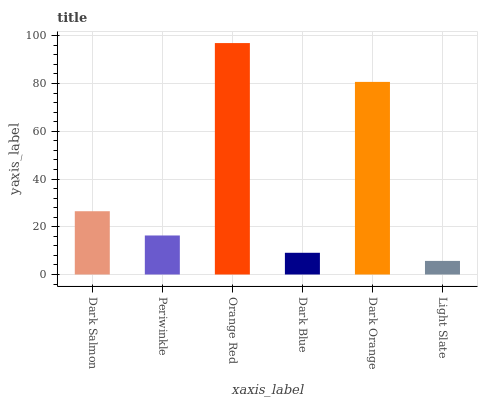Is Light Slate the minimum?
Answer yes or no. Yes. Is Orange Red the maximum?
Answer yes or no. Yes. Is Periwinkle the minimum?
Answer yes or no. No. Is Periwinkle the maximum?
Answer yes or no. No. Is Dark Salmon greater than Periwinkle?
Answer yes or no. Yes. Is Periwinkle less than Dark Salmon?
Answer yes or no. Yes. Is Periwinkle greater than Dark Salmon?
Answer yes or no. No. Is Dark Salmon less than Periwinkle?
Answer yes or no. No. Is Dark Salmon the high median?
Answer yes or no. Yes. Is Periwinkle the low median?
Answer yes or no. Yes. Is Periwinkle the high median?
Answer yes or no. No. Is Orange Red the low median?
Answer yes or no. No. 